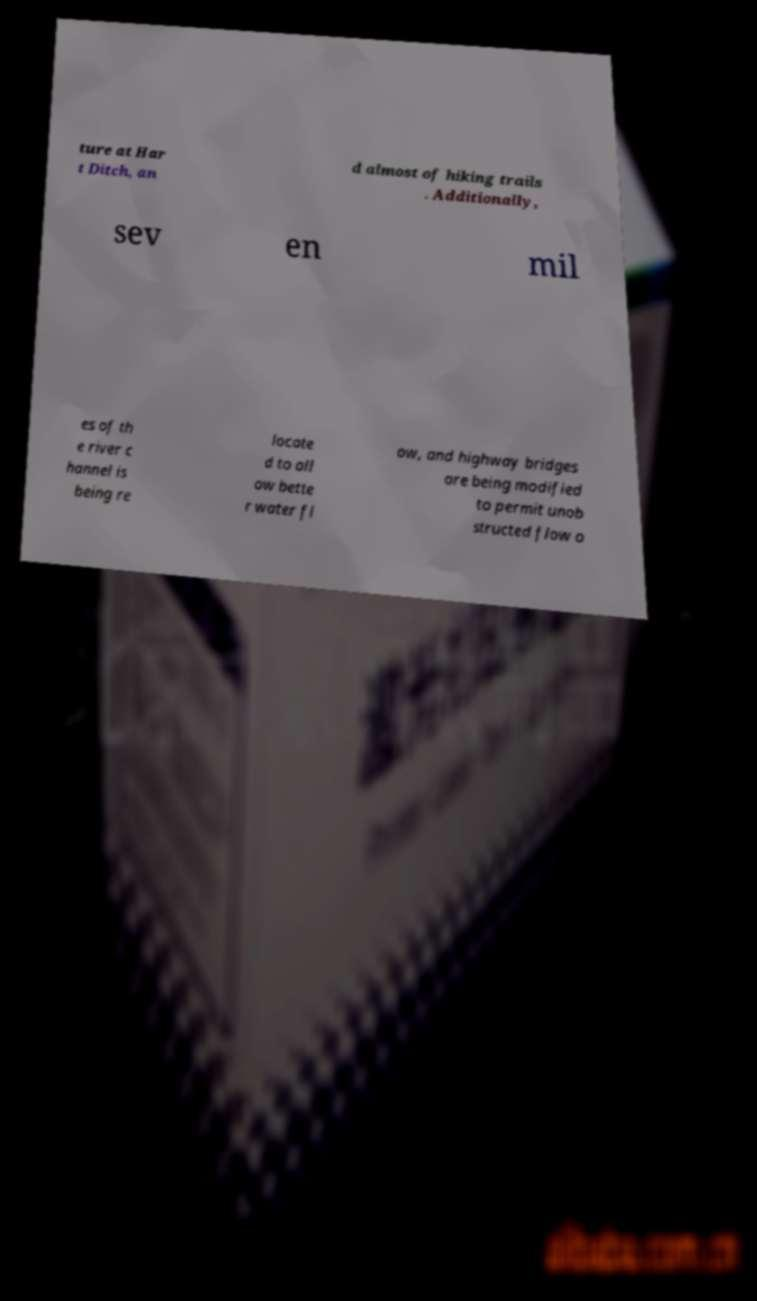I need the written content from this picture converted into text. Can you do that? ture at Har t Ditch, an d almost of hiking trails . Additionally, sev en mil es of th e river c hannel is being re locate d to all ow bette r water fl ow, and highway bridges are being modified to permit unob structed flow o 